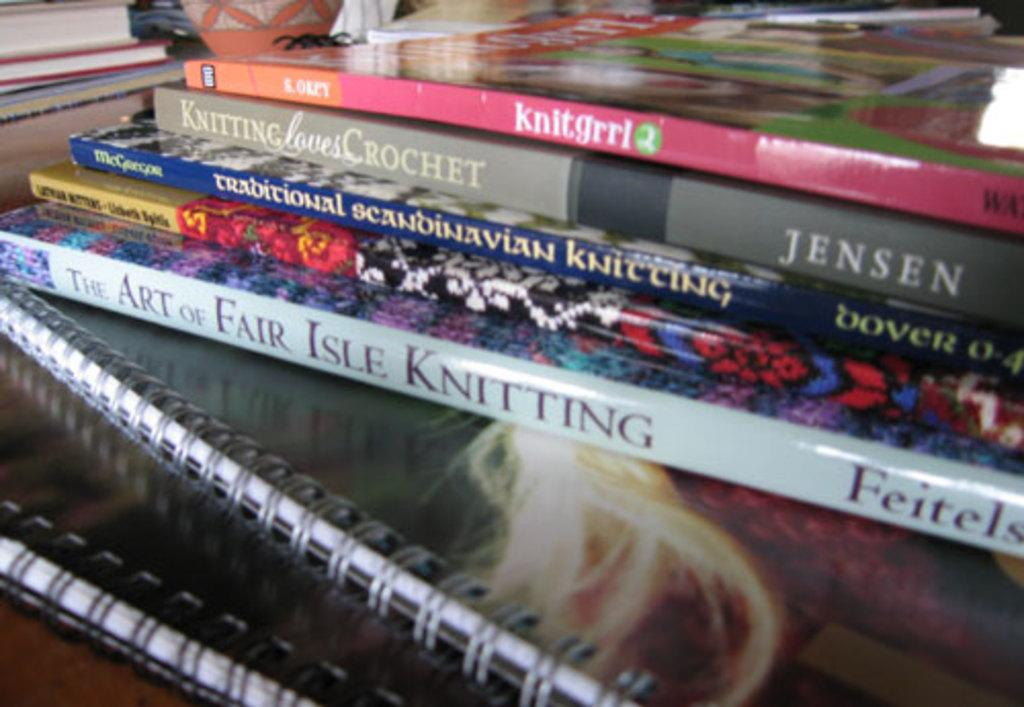<image>
Render a clear and concise summary of the photo. A stack of books with one titled knitgrrl on top. 